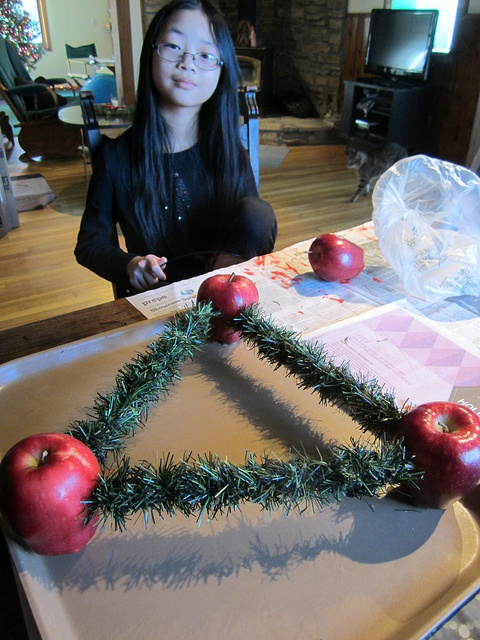Describe the objects in this image and their specific colors. I can see dining table in maroon, darkgray, black, lavender, and gray tones, people in maroon, black, navy, darkgray, and gray tones, apple in maroon, black, salmon, and brown tones, apple in maroon, black, salmon, and brown tones, and chair in maroon, black, teal, and darkblue tones in this image. 